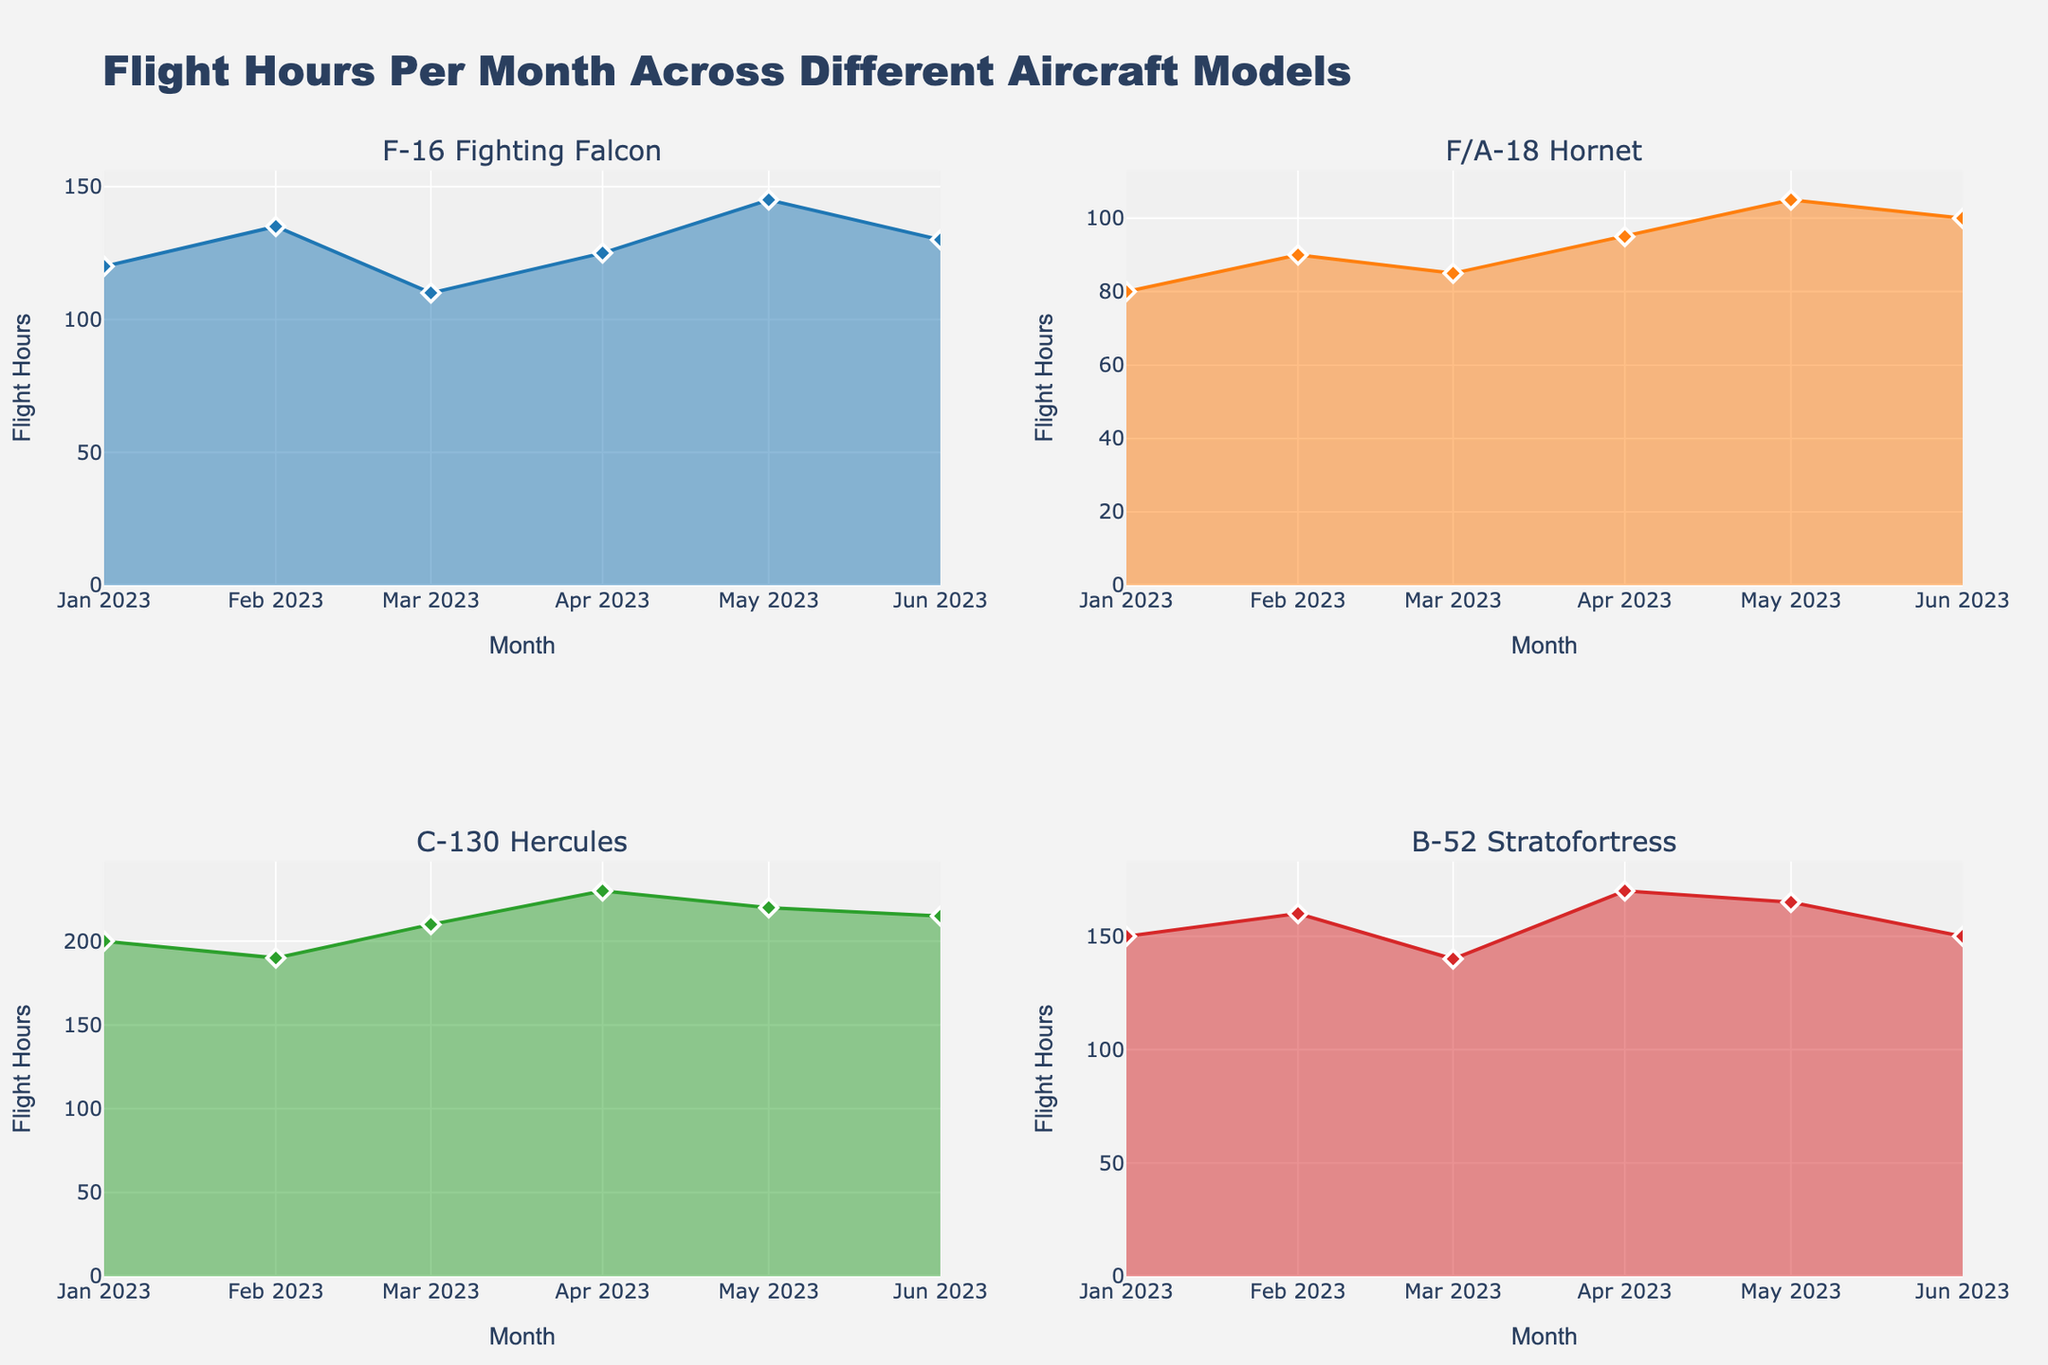Which aircraft model had the highest number of flight hours in January 2023? Look at the January 2023 data points for each subplot and identify the highest value. The C-130 Hercules had 200 flight hours, which is the highest.
Answer: C-130 Hercules What is the average flight hours for the F-16 Fighting Falcon from January to June 2023? Sum the flight hours for each month (120 + 135 + 110 + 125 + 145 + 130) and then divide by 6. The total is 765, so the average is 765 / 6 = 127.5
Answer: 127.5 Which month saw the highest flight hours for the B-52 Stratofortress? Look at each data point for the B-52 Stratofortress subplot and find the highest value. April 2023 has the highest flight hours with 170.
Answer: April 2023 By how many flight hours did the C-130 Hercules exceed the F/A-18 Hornet in March 2023? Identify the flight hours for both aircraft in March (C-130 Hercules: 210, F/A-18 Hornet: 85). Subtract the F/A-18 Hornet flight hours from the C-130 Hercules flight hours (210 - 85 = 125).
Answer: 125 Did the F/A-18 Hornet ever exceed 100 flight hours in any month? Examine the F/A-18 Hornet subplot to see if there is any month where the flight hours exceed 100. The maximum value it reached is 105 in May.
Answer: Yes Which aircraft model showed the most consistent flight hours over the months? Evaluate the variance/consistency in the flight hours across months for each subplot. The F/A-18 Hornet shows closer values (range from 80 to 105) compared to others.
Answer: F/A-18 Hornet How did the flight hours of the F-16 Fighting Falcon change from February to March 2023? Compare the flight hours in February (135) and March (110) for the F-16 Fighting Falcon and note the difference (135 - 110 = 25 flight hours decrease).
Answer: Decreased by 25 flight hours What is the combined total flight hours for all aircraft models for June 2023? Sum the June flight hours for each aircraft model (F-16 Fighting Falcon: 130, F/A-18 Hornet: 100, C-130 Hercules: 215, B-52 Stratofortress: 150). The combined total is (130 + 100 + 215 + 150) = 595.
Answer: 595 Which aircraft model had the largest increase in flight hours from January to June 2023? Calculate the difference in flight hours from January to June for each aircraft model. The F-16 Fighting Falcon increased from 120 to 130 (+10), F/A-18 Hornet from 80 to 100 (+20), C-130 Hercules from 200 to 215 (+15), and B-52 Stratofortress from 150 to 150 (+0). The F/A-18 Hornet had the largest increase of +20.
Answer: F/A-18 Hornet 